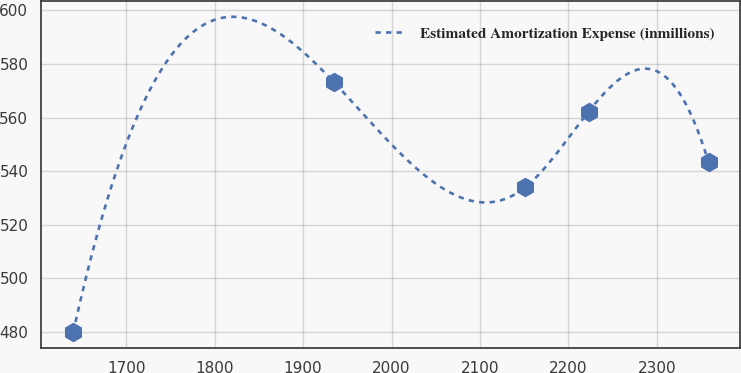Convert chart to OTSL. <chart><loc_0><loc_0><loc_500><loc_500><line_chart><ecel><fcel>Estimated Amortization Expense (inmillions)<nl><fcel>1640.24<fcel>479.83<nl><fcel>1935.05<fcel>573.18<nl><fcel>2150.91<fcel>533.93<nl><fcel>2222.73<fcel>562.23<nl><fcel>2358.41<fcel>543.26<nl></chart> 